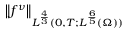<formula> <loc_0><loc_0><loc_500><loc_500>\left \| f ^ { \nu } \right \| _ { L ^ { \frac { 4 } { 3 } } ( 0 , T ; L ^ { \frac { 6 } { 5 } } ( \Omega ) ) }</formula> 